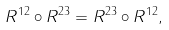<formula> <loc_0><loc_0><loc_500><loc_500>R ^ { 1 2 } \circ R ^ { 2 3 } = R ^ { 2 3 } \circ R ^ { 1 2 } ,</formula> 